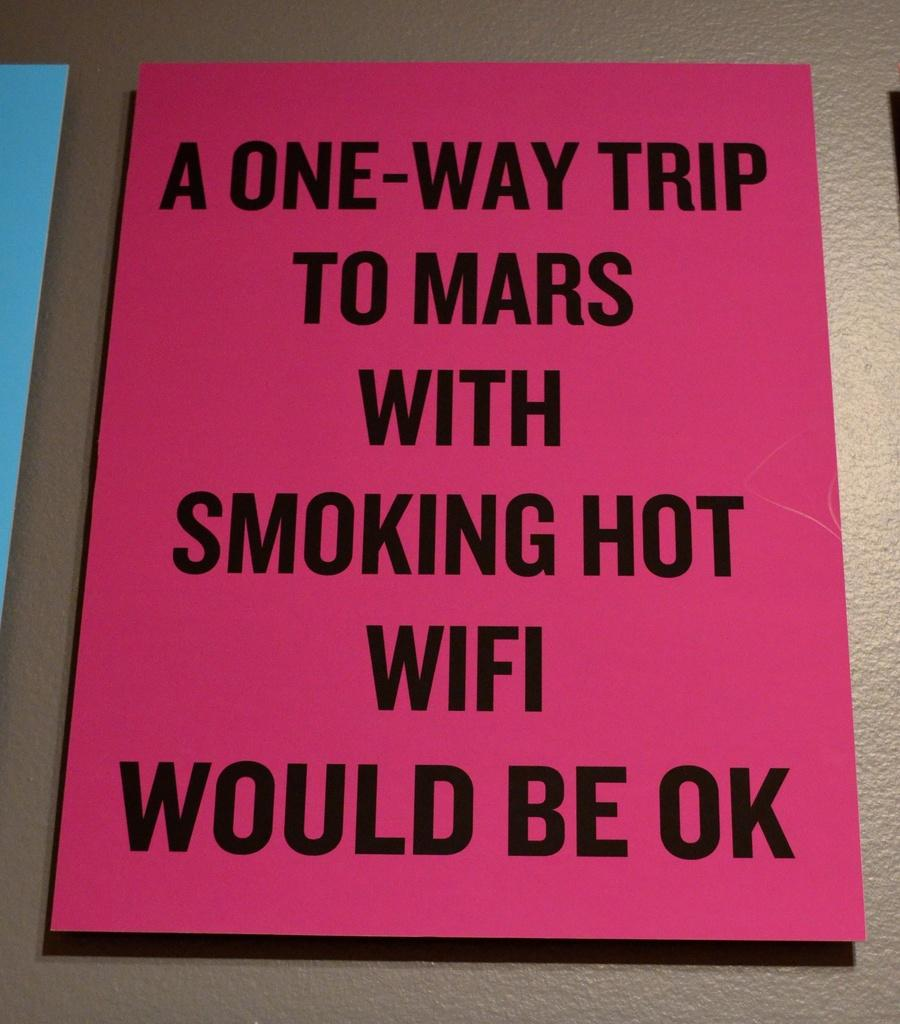<image>
Share a concise interpretation of the image provided. A pink sign about a one way trip to Mars. 